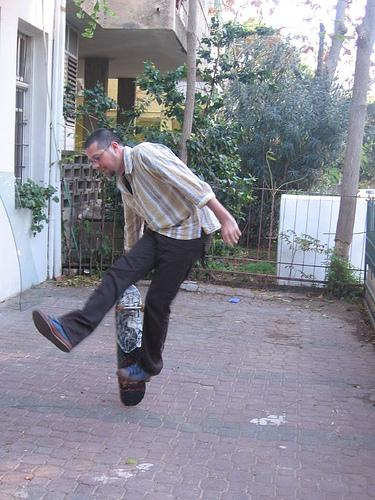Is this person at the front or back of the house?
Concise answer only. Back. What color are the man's pants?
Concise answer only. Black. How many feet are on ground?
Quick response, please. 0. 